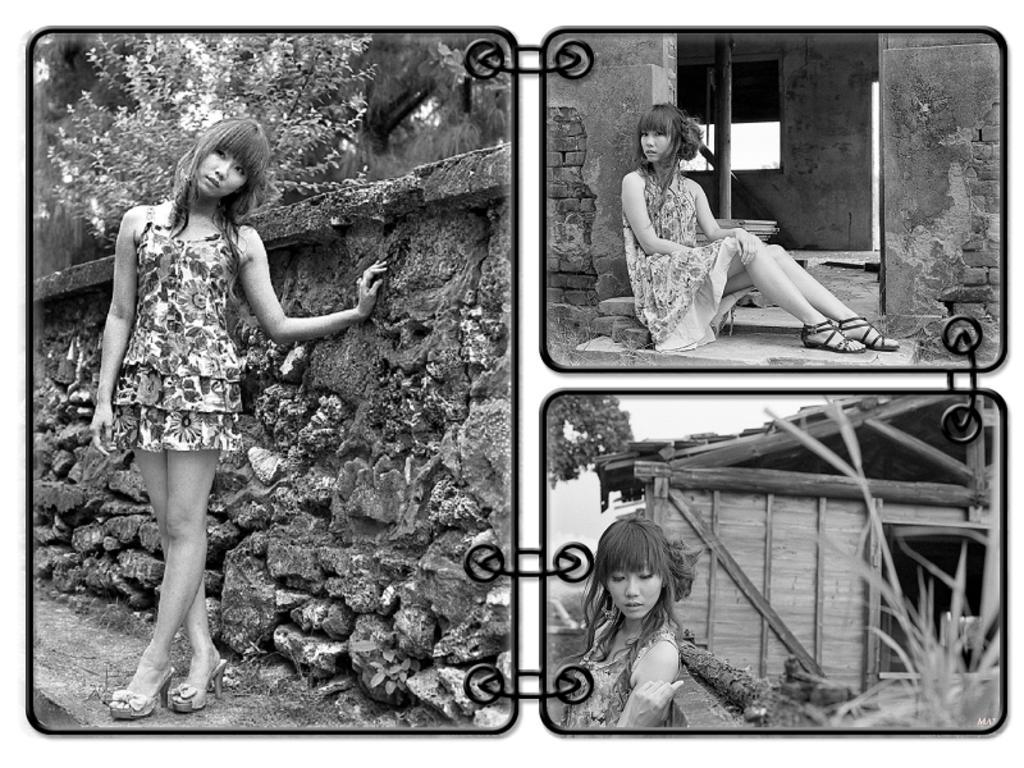Could you give a brief overview of what you see in this image? There is a collage image of three different pictures. In the first picture, there is a person standing in front of the wall. In the second picture, person is sitting on the ground. In the third picture, there is a person in front of the hut. 